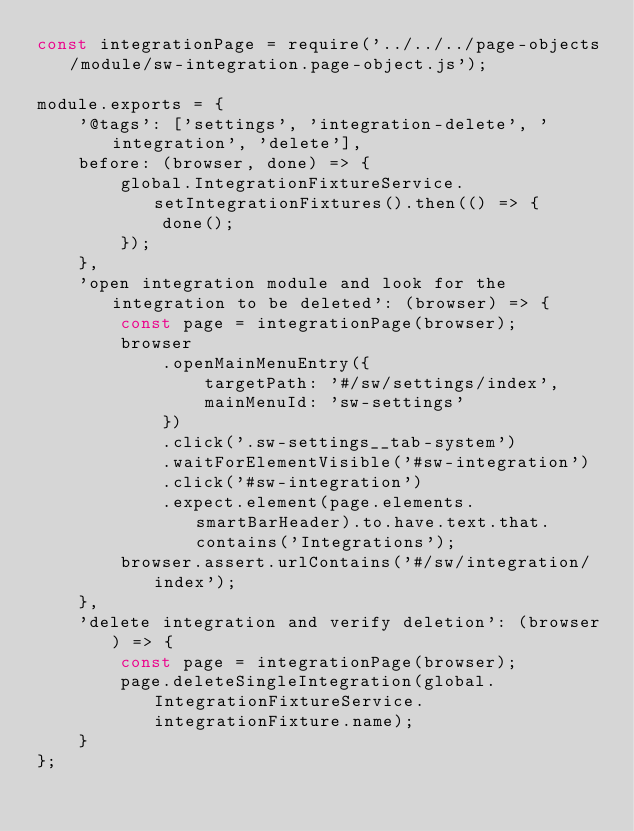<code> <loc_0><loc_0><loc_500><loc_500><_JavaScript_>const integrationPage = require('../../../page-objects/module/sw-integration.page-object.js');

module.exports = {
    '@tags': ['settings', 'integration-delete', 'integration', 'delete'],
    before: (browser, done) => {
        global.IntegrationFixtureService.setIntegrationFixtures().then(() => {
            done();
        });
    },
    'open integration module and look for the integration to be deleted': (browser) => {
        const page = integrationPage(browser);
        browser
            .openMainMenuEntry({
                targetPath: '#/sw/settings/index',
                mainMenuId: 'sw-settings'
            })
            .click('.sw-settings__tab-system')
            .waitForElementVisible('#sw-integration')
            .click('#sw-integration')
            .expect.element(page.elements.smartBarHeader).to.have.text.that.contains('Integrations');
        browser.assert.urlContains('#/sw/integration/index');
    },
    'delete integration and verify deletion': (browser) => {
        const page = integrationPage(browser);
        page.deleteSingleIntegration(global.IntegrationFixtureService.integrationFixture.name);
    }
};
</code> 